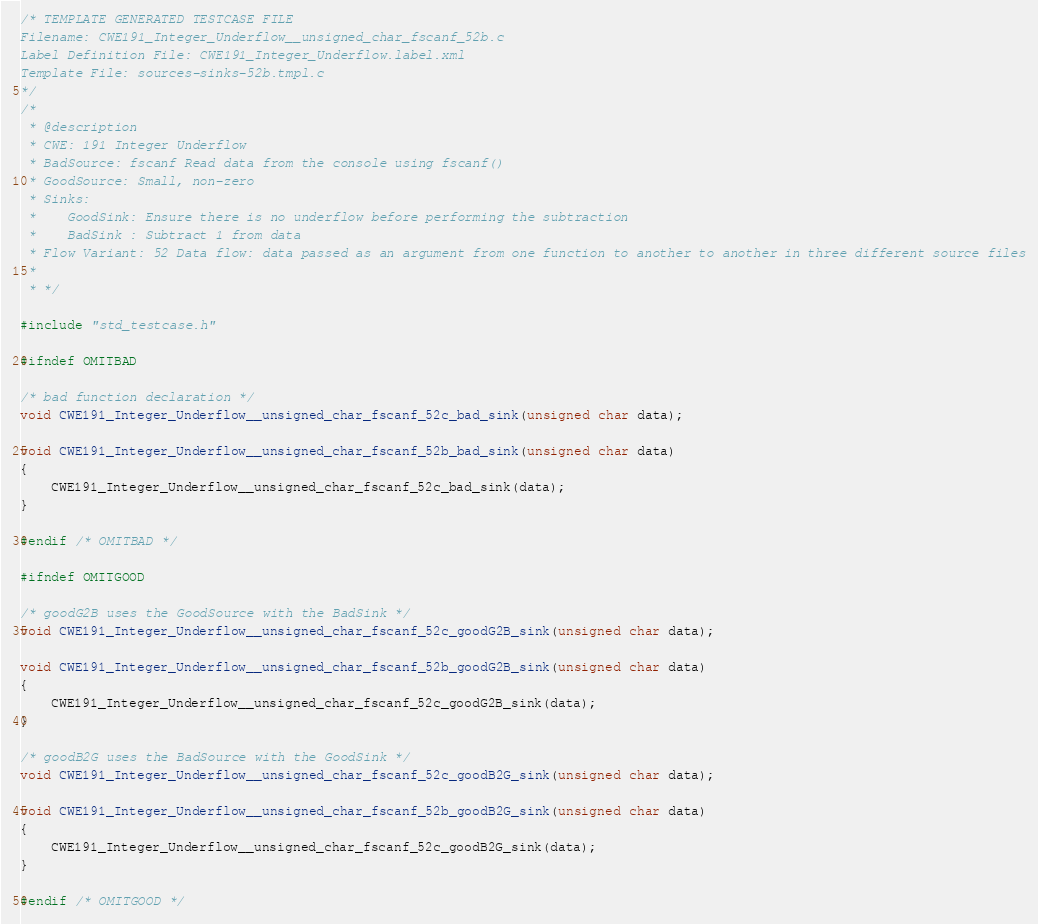Convert code to text. <code><loc_0><loc_0><loc_500><loc_500><_C_>/* TEMPLATE GENERATED TESTCASE FILE
Filename: CWE191_Integer_Underflow__unsigned_char_fscanf_52b.c
Label Definition File: CWE191_Integer_Underflow.label.xml
Template File: sources-sinks-52b.tmpl.c
*/
/*
 * @description
 * CWE: 191 Integer Underflow
 * BadSource: fscanf Read data from the console using fscanf()
 * GoodSource: Small, non-zero
 * Sinks:
 *    GoodSink: Ensure there is no underflow before performing the subtraction
 *    BadSink : Subtract 1 from data
 * Flow Variant: 52 Data flow: data passed as an argument from one function to another to another in three different source files
 *
 * */

#include "std_testcase.h"

#ifndef OMITBAD

/* bad function declaration */
void CWE191_Integer_Underflow__unsigned_char_fscanf_52c_bad_sink(unsigned char data);

void CWE191_Integer_Underflow__unsigned_char_fscanf_52b_bad_sink(unsigned char data)
{
    CWE191_Integer_Underflow__unsigned_char_fscanf_52c_bad_sink(data);
}

#endif /* OMITBAD */

#ifndef OMITGOOD

/* goodG2B uses the GoodSource with the BadSink */
void CWE191_Integer_Underflow__unsigned_char_fscanf_52c_goodG2B_sink(unsigned char data);

void CWE191_Integer_Underflow__unsigned_char_fscanf_52b_goodG2B_sink(unsigned char data)
{
    CWE191_Integer_Underflow__unsigned_char_fscanf_52c_goodG2B_sink(data);
}

/* goodB2G uses the BadSource with the GoodSink */
void CWE191_Integer_Underflow__unsigned_char_fscanf_52c_goodB2G_sink(unsigned char data);

void CWE191_Integer_Underflow__unsigned_char_fscanf_52b_goodB2G_sink(unsigned char data)
{
    CWE191_Integer_Underflow__unsigned_char_fscanf_52c_goodB2G_sink(data);
}

#endif /* OMITGOOD */
</code> 